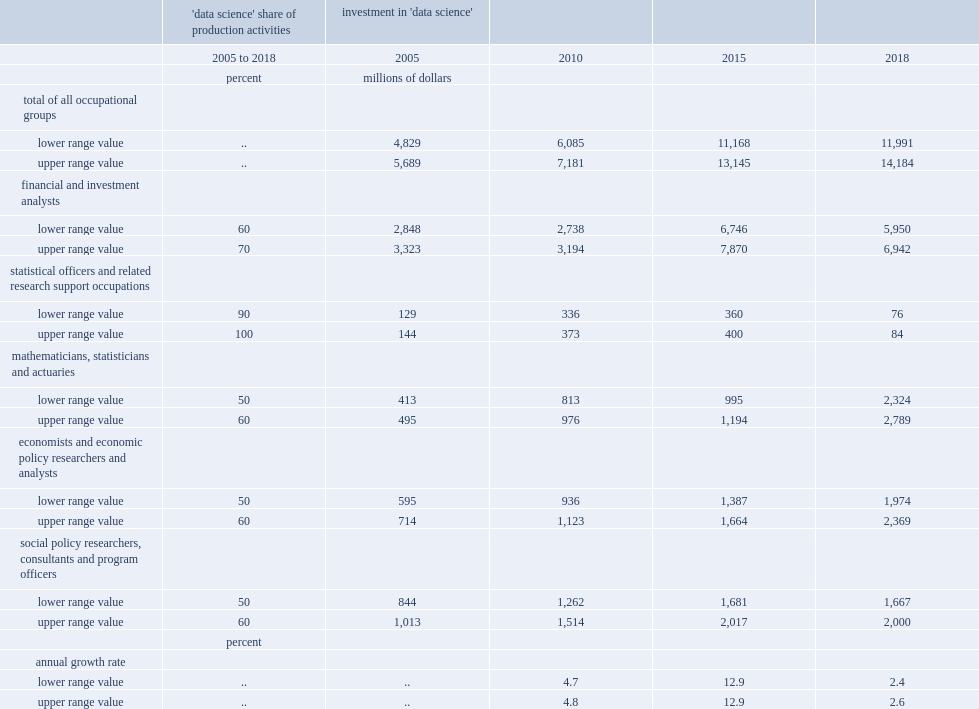What were the lower and upper range value of investment in 'data science' in 2018 respectively? 11991.0 14184.0. What were the annual rates of growth between 2005 and 2010, between 2010 and 2015 and between 2015 and 2018 respectively? 4.8 12.9 2.6. 